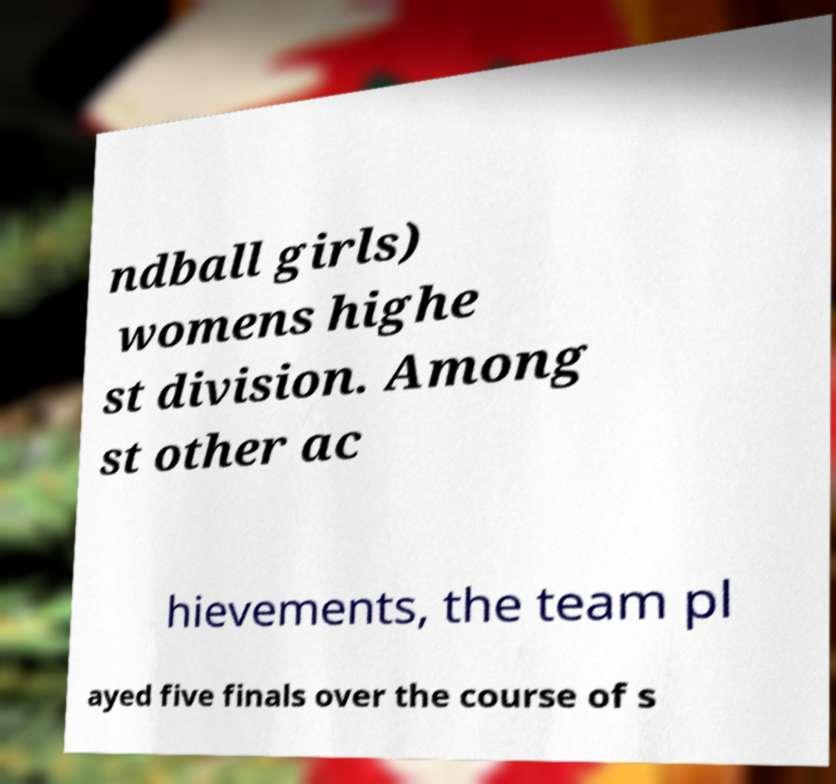Could you extract and type out the text from this image? ndball girls) womens highe st division. Among st other ac hievements, the team pl ayed five finals over the course of s 